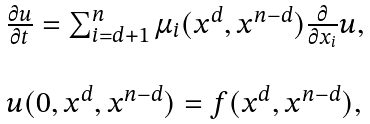<formula> <loc_0><loc_0><loc_500><loc_500>\begin{array} { l l } \frac { \partial u } { \partial t } = \sum _ { i = d + 1 } ^ { n } \mu _ { i } ( x ^ { d } , x ^ { n - d } ) \frac { \partial } { \partial x _ { i } } u , \\ \\ u ( 0 , x ^ { d } , x ^ { n - d } ) = f ( x ^ { d } , x ^ { n - d } ) , \end{array}</formula> 